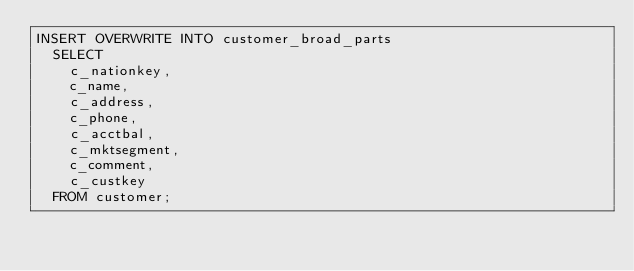<code> <loc_0><loc_0><loc_500><loc_500><_SQL_>INSERT OVERWRITE INTO customer_broad_parts
  SELECT
    c_nationkey,
    c_name,
    c_address,
    c_phone,
    c_acctbal,
    c_mktsegment,
    c_comment,
    c_custkey
  FROM customer;</code> 